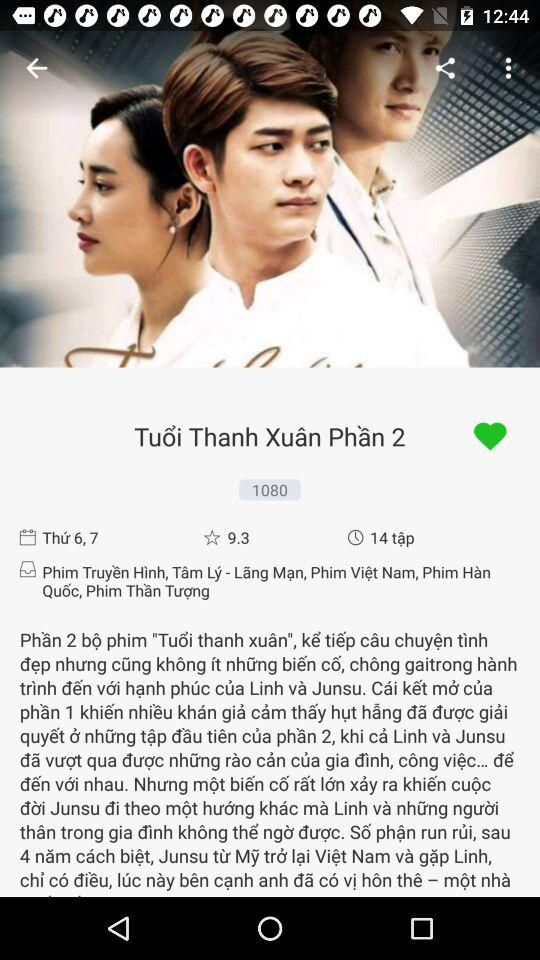What is the average rating of the show?
Answer the question using a single word or phrase. 9.3 